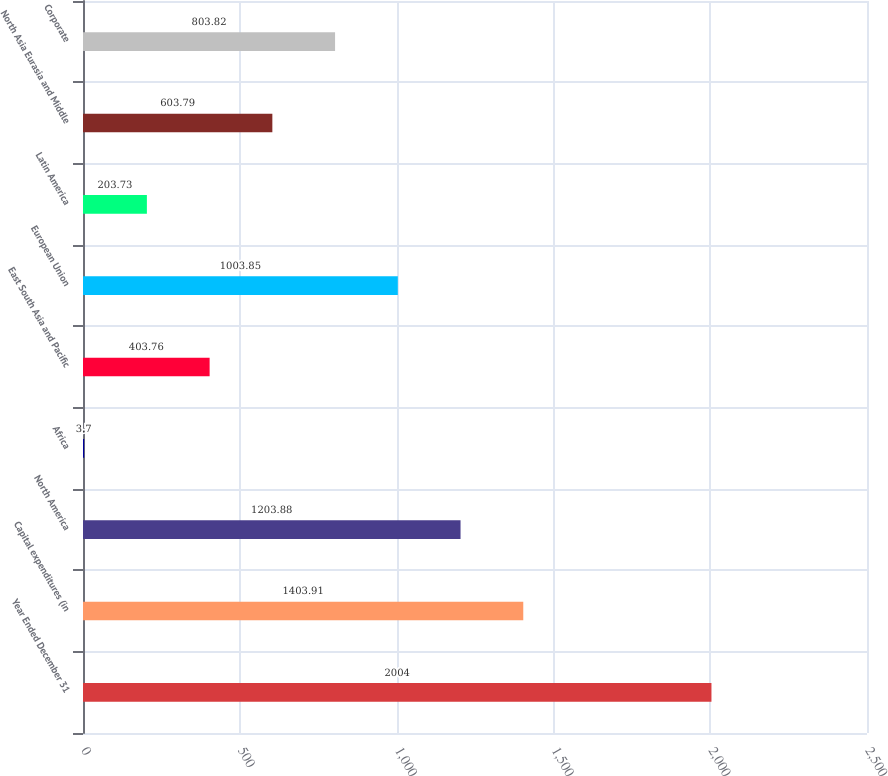Convert chart. <chart><loc_0><loc_0><loc_500><loc_500><bar_chart><fcel>Year Ended December 31<fcel>Capital expenditures (in<fcel>North America<fcel>Africa<fcel>East South Asia and Pacific<fcel>European Union<fcel>Latin America<fcel>North Asia Eurasia and Middle<fcel>Corporate<nl><fcel>2004<fcel>1403.91<fcel>1203.88<fcel>3.7<fcel>403.76<fcel>1003.85<fcel>203.73<fcel>603.79<fcel>803.82<nl></chart> 